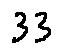<formula> <loc_0><loc_0><loc_500><loc_500>3 3</formula> 